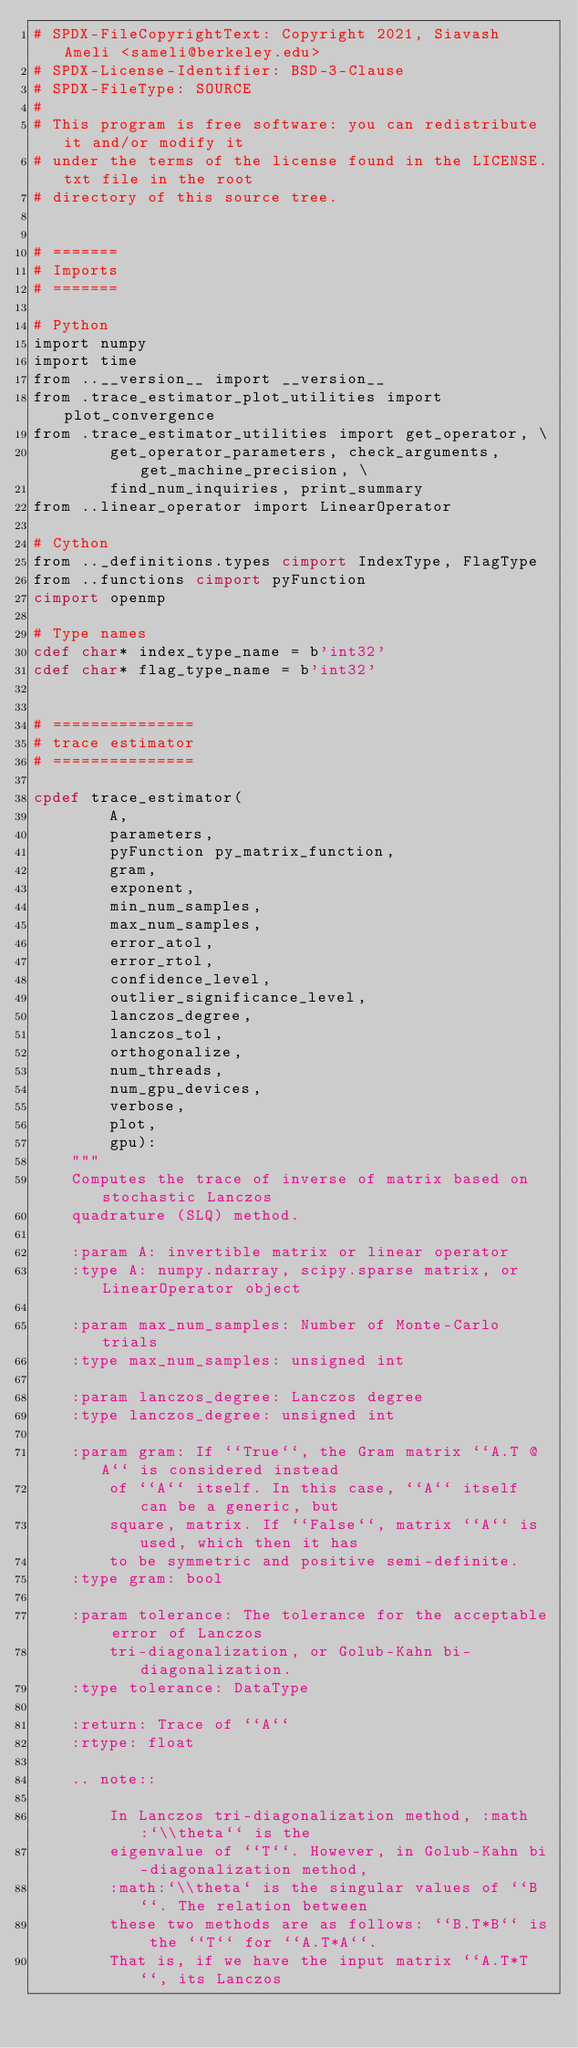<code> <loc_0><loc_0><loc_500><loc_500><_Cython_># SPDX-FileCopyrightText: Copyright 2021, Siavash Ameli <sameli@berkeley.edu>
# SPDX-License-Identifier: BSD-3-Clause
# SPDX-FileType: SOURCE
#
# This program is free software: you can redistribute it and/or modify it
# under the terms of the license found in the LICENSE.txt file in the root
# directory of this source tree.


# =======
# Imports
# =======

# Python
import numpy
import time
from ..__version__ import __version__
from .trace_estimator_plot_utilities import plot_convergence
from .trace_estimator_utilities import get_operator, \
        get_operator_parameters, check_arguments, get_machine_precision, \
        find_num_inquiries, print_summary
from ..linear_operator import LinearOperator

# Cython
from .._definitions.types cimport IndexType, FlagType
from ..functions cimport pyFunction
cimport openmp

# Type names
cdef char* index_type_name = b'int32'
cdef char* flag_type_name = b'int32'


# ===============
# trace estimator
# ===============

cpdef trace_estimator(
        A,
        parameters,
        pyFunction py_matrix_function,
        gram,
        exponent,
        min_num_samples,
        max_num_samples,
        error_atol,
        error_rtol,
        confidence_level,
        outlier_significance_level,
        lanczos_degree,
        lanczos_tol,
        orthogonalize,
        num_threads,
        num_gpu_devices,
        verbose,
        plot,
        gpu):
    """
    Computes the trace of inverse of matrix based on stochastic Lanczos
    quadrature (SLQ) method.

    :param A: invertible matrix or linear operator
    :type A: numpy.ndarray, scipy.sparse matrix, or LinearOperator object

    :param max_num_samples: Number of Monte-Carlo trials
    :type max_num_samples: unsigned int

    :param lanczos_degree: Lanczos degree
    :type lanczos_degree: unsigned int

    :param gram: If ``True``, the Gram matrix ``A.T @ A`` is considered instead
        of ``A`` itself. In this case, ``A`` itself can be a generic, but
        square, matrix. If ``False``, matrix ``A`` is used, which then it has
        to be symmetric and positive semi-definite.
    :type gram: bool

    :param tolerance: The tolerance for the acceptable error of Lanczos
        tri-diagonalization, or Golub-Kahn bi-diagonalization.
    :type tolerance: DataType

    :return: Trace of ``A``
    :rtype: float

    .. note::

        In Lanczos tri-diagonalization method, :math:`\\theta`` is the
        eigenvalue of ``T``. However, in Golub-Kahn bi-diagonalization method,
        :math:`\\theta` is the singular values of ``B``. The relation between
        these two methods are as follows: ``B.T*B`` is the ``T`` for ``A.T*A``.
        That is, if we have the input matrix ``A.T*T``, its Lanczos</code> 